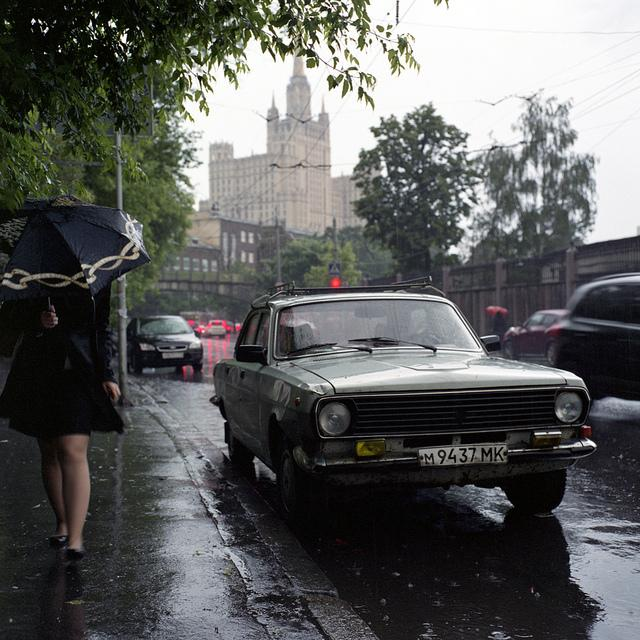What is the danger faced by the woman on the left?

Choices:
A) getting hit
B) tornado
C) getting sunburned
D) getting splashed getting splashed 